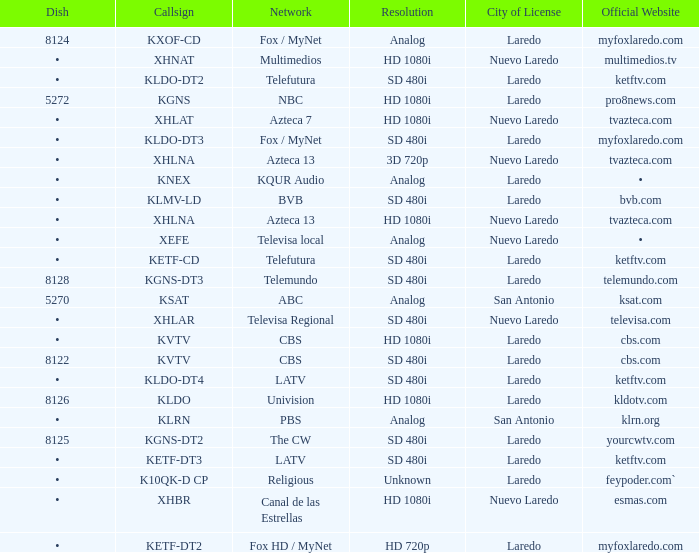Could you parse the entire table? {'header': ['Dish', 'Callsign', 'Network', 'Resolution', 'City of License', 'Official Website'], 'rows': [['8124', 'KXOF-CD', 'Fox / MyNet', 'Analog', 'Laredo', 'myfoxlaredo.com'], ['•', 'XHNAT', 'Multimedios', 'HD 1080i', 'Nuevo Laredo', 'multimedios.tv'], ['•', 'KLDO-DT2', 'Telefutura', 'SD 480i', 'Laredo', 'ketftv.com'], ['5272', 'KGNS', 'NBC', 'HD 1080i', 'Laredo', 'pro8news.com'], ['•', 'XHLAT', 'Azteca 7', 'HD 1080i', 'Nuevo Laredo', 'tvazteca.com'], ['•', 'KLDO-DT3', 'Fox / MyNet', 'SD 480i', 'Laredo', 'myfoxlaredo.com'], ['•', 'XHLNA', 'Azteca 13', '3D 720p', 'Nuevo Laredo', 'tvazteca.com'], ['•', 'KNEX', 'KQUR Audio', 'Analog', 'Laredo', '•'], ['•', 'KLMV-LD', 'BVB', 'SD 480i', 'Laredo', 'bvb.com'], ['•', 'XHLNA', 'Azteca 13', 'HD 1080i', 'Nuevo Laredo', 'tvazteca.com'], ['•', 'XEFE', 'Televisa local', 'Analog', 'Nuevo Laredo', '•'], ['•', 'KETF-CD', 'Telefutura', 'SD 480i', 'Laredo', 'ketftv.com'], ['8128', 'KGNS-DT3', 'Telemundo', 'SD 480i', 'Laredo', 'telemundo.com'], ['5270', 'KSAT', 'ABC', 'Analog', 'San Antonio', 'ksat.com'], ['•', 'XHLAR', 'Televisa Regional', 'SD 480i', 'Nuevo Laredo', 'televisa.com'], ['•', 'KVTV', 'CBS', 'HD 1080i', 'Laredo', 'cbs.com'], ['8122', 'KVTV', 'CBS', 'SD 480i', 'Laredo', 'cbs.com'], ['•', 'KLDO-DT4', 'LATV', 'SD 480i', 'Laredo', 'ketftv.com'], ['8126', 'KLDO', 'Univision', 'HD 1080i', 'Laredo', 'kldotv.com'], ['•', 'KLRN', 'PBS', 'Analog', 'San Antonio', 'klrn.org'], ['8125', 'KGNS-DT2', 'The CW', 'SD 480i', 'Laredo', 'yourcwtv.com'], ['•', 'KETF-DT3', 'LATV', 'SD 480i', 'Laredo', 'ketftv.com'], ['•', 'K10QK-D CP', 'Religious', 'Unknown', 'Laredo', 'feypoder.com`'], ['•', 'XHBR', 'Canal de las Estrellas', 'HD 1080i', 'Nuevo Laredo', 'esmas.com'], ['•', 'KETF-DT2', 'Fox HD / MyNet', 'HD 720p', 'Laredo', 'myfoxlaredo.com']]} Name the official website which has dish of • and callsign of kvtv Cbs.com. 